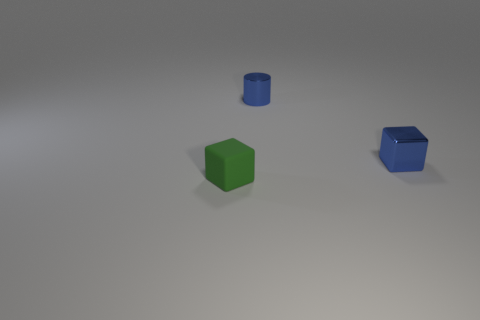Add 2 tiny green things. How many objects exist? 5 Subtract all cylinders. How many objects are left? 2 Subtract all large red spheres. Subtract all shiny cylinders. How many objects are left? 2 Add 2 tiny blue cubes. How many tiny blue cubes are left? 3 Add 2 large brown blocks. How many large brown blocks exist? 2 Subtract 1 green blocks. How many objects are left? 2 